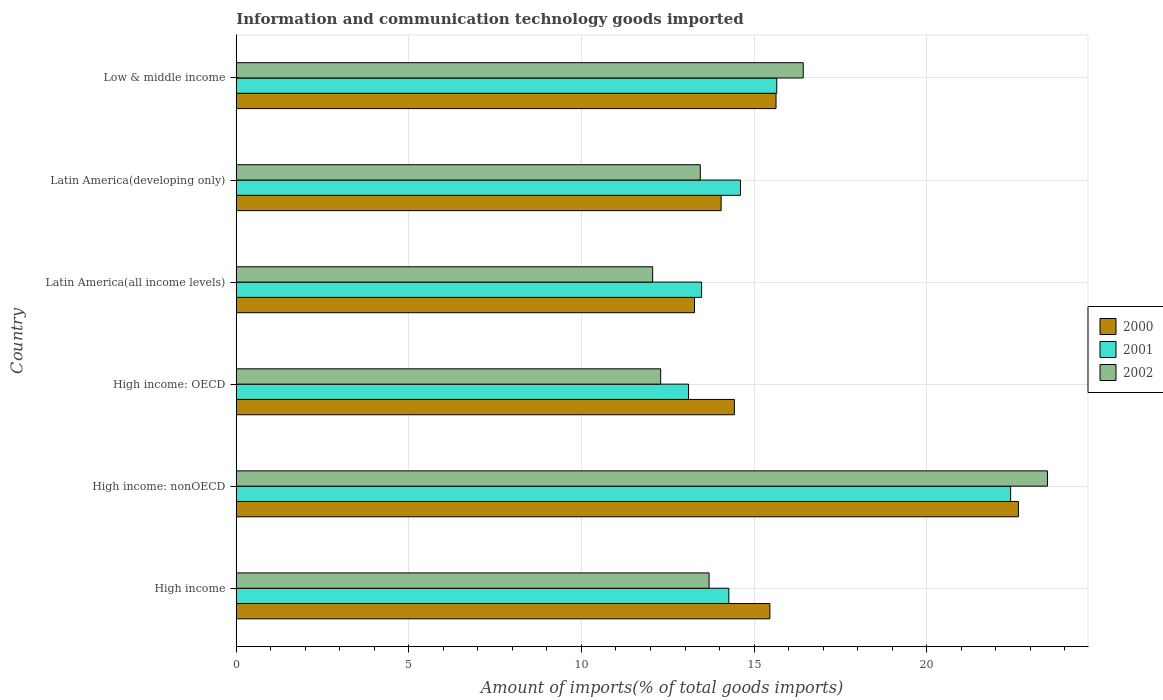How many different coloured bars are there?
Your response must be concise. 3. How many groups of bars are there?
Give a very brief answer. 6. Are the number of bars on each tick of the Y-axis equal?
Make the answer very short. Yes. How many bars are there on the 1st tick from the top?
Keep it short and to the point. 3. What is the label of the 5th group of bars from the top?
Provide a succinct answer. High income: nonOECD. In how many cases, is the number of bars for a given country not equal to the number of legend labels?
Ensure brevity in your answer.  0. What is the amount of goods imported in 2000 in High income: OECD?
Make the answer very short. 14.43. Across all countries, what is the maximum amount of goods imported in 2000?
Offer a terse response. 22.66. Across all countries, what is the minimum amount of goods imported in 2000?
Your response must be concise. 13.27. In which country was the amount of goods imported in 2000 maximum?
Keep it short and to the point. High income: nonOECD. In which country was the amount of goods imported in 2002 minimum?
Provide a short and direct response. Latin America(all income levels). What is the total amount of goods imported in 2002 in the graph?
Offer a very short reply. 91.42. What is the difference between the amount of goods imported in 2002 in High income and that in High income: OECD?
Your response must be concise. 1.4. What is the difference between the amount of goods imported in 2000 in High income and the amount of goods imported in 2002 in High income: nonOECD?
Offer a very short reply. -8.04. What is the average amount of goods imported in 2001 per country?
Your answer should be very brief. 15.59. What is the difference between the amount of goods imported in 2001 and amount of goods imported in 2000 in Latin America(developing only)?
Your response must be concise. 0.56. In how many countries, is the amount of goods imported in 2000 greater than 7 %?
Offer a terse response. 6. What is the ratio of the amount of goods imported in 2000 in High income: OECD to that in High income: nonOECD?
Keep it short and to the point. 0.64. Is the difference between the amount of goods imported in 2001 in High income: nonOECD and Latin America(all income levels) greater than the difference between the amount of goods imported in 2000 in High income: nonOECD and Latin America(all income levels)?
Provide a short and direct response. No. What is the difference between the highest and the second highest amount of goods imported in 2000?
Provide a succinct answer. 7.02. What is the difference between the highest and the lowest amount of goods imported in 2001?
Your answer should be compact. 9.33. In how many countries, is the amount of goods imported in 2001 greater than the average amount of goods imported in 2001 taken over all countries?
Keep it short and to the point. 2. Is the sum of the amount of goods imported in 2002 in Latin America(all income levels) and Low & middle income greater than the maximum amount of goods imported in 2000 across all countries?
Keep it short and to the point. Yes. What does the 3rd bar from the bottom in High income: OECD represents?
Your answer should be very brief. 2002. How many bars are there?
Make the answer very short. 18. Are all the bars in the graph horizontal?
Your response must be concise. Yes. What is the difference between two consecutive major ticks on the X-axis?
Ensure brevity in your answer.  5. Does the graph contain any zero values?
Give a very brief answer. No. Where does the legend appear in the graph?
Your response must be concise. Center right. How many legend labels are there?
Give a very brief answer. 3. What is the title of the graph?
Ensure brevity in your answer.  Information and communication technology goods imported. What is the label or title of the X-axis?
Provide a short and direct response. Amount of imports(% of total goods imports). What is the label or title of the Y-axis?
Keep it short and to the point. Country. What is the Amount of imports(% of total goods imports) in 2000 in High income?
Offer a terse response. 15.46. What is the Amount of imports(% of total goods imports) of 2001 in High income?
Keep it short and to the point. 14.27. What is the Amount of imports(% of total goods imports) of 2002 in High income?
Give a very brief answer. 13.7. What is the Amount of imports(% of total goods imports) in 2000 in High income: nonOECD?
Offer a very short reply. 22.66. What is the Amount of imports(% of total goods imports) in 2001 in High income: nonOECD?
Give a very brief answer. 22.43. What is the Amount of imports(% of total goods imports) of 2002 in High income: nonOECD?
Provide a succinct answer. 23.5. What is the Amount of imports(% of total goods imports) in 2000 in High income: OECD?
Give a very brief answer. 14.43. What is the Amount of imports(% of total goods imports) in 2001 in High income: OECD?
Provide a succinct answer. 13.1. What is the Amount of imports(% of total goods imports) of 2002 in High income: OECD?
Offer a very short reply. 12.3. What is the Amount of imports(% of total goods imports) of 2000 in Latin America(all income levels)?
Make the answer very short. 13.27. What is the Amount of imports(% of total goods imports) of 2001 in Latin America(all income levels)?
Ensure brevity in your answer.  13.48. What is the Amount of imports(% of total goods imports) of 2002 in Latin America(all income levels)?
Offer a very short reply. 12.06. What is the Amount of imports(% of total goods imports) in 2000 in Latin America(developing only)?
Make the answer very short. 14.05. What is the Amount of imports(% of total goods imports) of 2001 in Latin America(developing only)?
Your answer should be compact. 14.61. What is the Amount of imports(% of total goods imports) in 2002 in Latin America(developing only)?
Make the answer very short. 13.44. What is the Amount of imports(% of total goods imports) of 2000 in Low & middle income?
Make the answer very short. 15.64. What is the Amount of imports(% of total goods imports) in 2001 in Low & middle income?
Your answer should be very brief. 15.66. What is the Amount of imports(% of total goods imports) of 2002 in Low & middle income?
Your answer should be compact. 16.42. Across all countries, what is the maximum Amount of imports(% of total goods imports) of 2000?
Provide a succinct answer. 22.66. Across all countries, what is the maximum Amount of imports(% of total goods imports) of 2001?
Ensure brevity in your answer.  22.43. Across all countries, what is the maximum Amount of imports(% of total goods imports) of 2002?
Your response must be concise. 23.5. Across all countries, what is the minimum Amount of imports(% of total goods imports) of 2000?
Give a very brief answer. 13.27. Across all countries, what is the minimum Amount of imports(% of total goods imports) of 2001?
Offer a terse response. 13.1. Across all countries, what is the minimum Amount of imports(% of total goods imports) in 2002?
Make the answer very short. 12.06. What is the total Amount of imports(% of total goods imports) of 2000 in the graph?
Offer a very short reply. 95.5. What is the total Amount of imports(% of total goods imports) of 2001 in the graph?
Ensure brevity in your answer.  93.55. What is the total Amount of imports(% of total goods imports) of 2002 in the graph?
Provide a succinct answer. 91.42. What is the difference between the Amount of imports(% of total goods imports) of 2000 in High income and that in High income: nonOECD?
Offer a terse response. -7.2. What is the difference between the Amount of imports(% of total goods imports) in 2001 in High income and that in High income: nonOECD?
Your answer should be compact. -8.16. What is the difference between the Amount of imports(% of total goods imports) of 2002 in High income and that in High income: nonOECD?
Offer a terse response. -9.8. What is the difference between the Amount of imports(% of total goods imports) in 2000 in High income and that in High income: OECD?
Offer a terse response. 1.03. What is the difference between the Amount of imports(% of total goods imports) of 2001 in High income and that in High income: OECD?
Your answer should be very brief. 1.17. What is the difference between the Amount of imports(% of total goods imports) in 2002 in High income and that in High income: OECD?
Your response must be concise. 1.4. What is the difference between the Amount of imports(% of total goods imports) in 2000 in High income and that in Latin America(all income levels)?
Ensure brevity in your answer.  2.18. What is the difference between the Amount of imports(% of total goods imports) of 2001 in High income and that in Latin America(all income levels)?
Offer a terse response. 0.79. What is the difference between the Amount of imports(% of total goods imports) of 2002 in High income and that in Latin America(all income levels)?
Give a very brief answer. 1.63. What is the difference between the Amount of imports(% of total goods imports) of 2000 in High income and that in Latin America(developing only)?
Give a very brief answer. 1.41. What is the difference between the Amount of imports(% of total goods imports) in 2001 in High income and that in Latin America(developing only)?
Your answer should be compact. -0.34. What is the difference between the Amount of imports(% of total goods imports) in 2002 in High income and that in Latin America(developing only)?
Your response must be concise. 0.25. What is the difference between the Amount of imports(% of total goods imports) of 2000 in High income and that in Low & middle income?
Make the answer very short. -0.18. What is the difference between the Amount of imports(% of total goods imports) in 2001 in High income and that in Low & middle income?
Offer a very short reply. -1.39. What is the difference between the Amount of imports(% of total goods imports) in 2002 in High income and that in Low & middle income?
Offer a very short reply. -2.73. What is the difference between the Amount of imports(% of total goods imports) in 2000 in High income: nonOECD and that in High income: OECD?
Provide a succinct answer. 8.23. What is the difference between the Amount of imports(% of total goods imports) in 2001 in High income: nonOECD and that in High income: OECD?
Make the answer very short. 9.33. What is the difference between the Amount of imports(% of total goods imports) in 2002 in High income: nonOECD and that in High income: OECD?
Provide a succinct answer. 11.2. What is the difference between the Amount of imports(% of total goods imports) of 2000 in High income: nonOECD and that in Latin America(all income levels)?
Your response must be concise. 9.38. What is the difference between the Amount of imports(% of total goods imports) of 2001 in High income: nonOECD and that in Latin America(all income levels)?
Keep it short and to the point. 8.95. What is the difference between the Amount of imports(% of total goods imports) of 2002 in High income: nonOECD and that in Latin America(all income levels)?
Ensure brevity in your answer.  11.44. What is the difference between the Amount of imports(% of total goods imports) of 2000 in High income: nonOECD and that in Latin America(developing only)?
Offer a very short reply. 8.61. What is the difference between the Amount of imports(% of total goods imports) of 2001 in High income: nonOECD and that in Latin America(developing only)?
Your answer should be very brief. 7.83. What is the difference between the Amount of imports(% of total goods imports) of 2002 in High income: nonOECD and that in Latin America(developing only)?
Make the answer very short. 10.06. What is the difference between the Amount of imports(% of total goods imports) of 2000 in High income: nonOECD and that in Low & middle income?
Make the answer very short. 7.02. What is the difference between the Amount of imports(% of total goods imports) of 2001 in High income: nonOECD and that in Low & middle income?
Keep it short and to the point. 6.78. What is the difference between the Amount of imports(% of total goods imports) of 2002 in High income: nonOECD and that in Low & middle income?
Ensure brevity in your answer.  7.07. What is the difference between the Amount of imports(% of total goods imports) of 2000 in High income: OECD and that in Latin America(all income levels)?
Ensure brevity in your answer.  1.15. What is the difference between the Amount of imports(% of total goods imports) of 2001 in High income: OECD and that in Latin America(all income levels)?
Keep it short and to the point. -0.38. What is the difference between the Amount of imports(% of total goods imports) of 2002 in High income: OECD and that in Latin America(all income levels)?
Provide a succinct answer. 0.23. What is the difference between the Amount of imports(% of total goods imports) of 2000 in High income: OECD and that in Latin America(developing only)?
Your response must be concise. 0.38. What is the difference between the Amount of imports(% of total goods imports) of 2001 in High income: OECD and that in Latin America(developing only)?
Ensure brevity in your answer.  -1.5. What is the difference between the Amount of imports(% of total goods imports) in 2002 in High income: OECD and that in Latin America(developing only)?
Keep it short and to the point. -1.15. What is the difference between the Amount of imports(% of total goods imports) of 2000 in High income: OECD and that in Low & middle income?
Make the answer very short. -1.21. What is the difference between the Amount of imports(% of total goods imports) of 2001 in High income: OECD and that in Low & middle income?
Offer a very short reply. -2.56. What is the difference between the Amount of imports(% of total goods imports) in 2002 in High income: OECD and that in Low & middle income?
Provide a short and direct response. -4.13. What is the difference between the Amount of imports(% of total goods imports) in 2000 in Latin America(all income levels) and that in Latin America(developing only)?
Your response must be concise. -0.77. What is the difference between the Amount of imports(% of total goods imports) of 2001 in Latin America(all income levels) and that in Latin America(developing only)?
Make the answer very short. -1.13. What is the difference between the Amount of imports(% of total goods imports) in 2002 in Latin America(all income levels) and that in Latin America(developing only)?
Your answer should be compact. -1.38. What is the difference between the Amount of imports(% of total goods imports) of 2000 in Latin America(all income levels) and that in Low & middle income?
Your response must be concise. -2.36. What is the difference between the Amount of imports(% of total goods imports) of 2001 in Latin America(all income levels) and that in Low & middle income?
Your answer should be compact. -2.18. What is the difference between the Amount of imports(% of total goods imports) of 2002 in Latin America(all income levels) and that in Low & middle income?
Provide a short and direct response. -4.36. What is the difference between the Amount of imports(% of total goods imports) in 2000 in Latin America(developing only) and that in Low & middle income?
Your response must be concise. -1.59. What is the difference between the Amount of imports(% of total goods imports) in 2001 in Latin America(developing only) and that in Low & middle income?
Offer a terse response. -1.05. What is the difference between the Amount of imports(% of total goods imports) in 2002 in Latin America(developing only) and that in Low & middle income?
Ensure brevity in your answer.  -2.98. What is the difference between the Amount of imports(% of total goods imports) in 2000 in High income and the Amount of imports(% of total goods imports) in 2001 in High income: nonOECD?
Offer a very short reply. -6.97. What is the difference between the Amount of imports(% of total goods imports) of 2000 in High income and the Amount of imports(% of total goods imports) of 2002 in High income: nonOECD?
Give a very brief answer. -8.04. What is the difference between the Amount of imports(% of total goods imports) of 2001 in High income and the Amount of imports(% of total goods imports) of 2002 in High income: nonOECD?
Your answer should be very brief. -9.23. What is the difference between the Amount of imports(% of total goods imports) in 2000 in High income and the Amount of imports(% of total goods imports) in 2001 in High income: OECD?
Give a very brief answer. 2.36. What is the difference between the Amount of imports(% of total goods imports) of 2000 in High income and the Amount of imports(% of total goods imports) of 2002 in High income: OECD?
Give a very brief answer. 3.16. What is the difference between the Amount of imports(% of total goods imports) in 2001 in High income and the Amount of imports(% of total goods imports) in 2002 in High income: OECD?
Provide a short and direct response. 1.97. What is the difference between the Amount of imports(% of total goods imports) in 2000 in High income and the Amount of imports(% of total goods imports) in 2001 in Latin America(all income levels)?
Make the answer very short. 1.98. What is the difference between the Amount of imports(% of total goods imports) of 2000 in High income and the Amount of imports(% of total goods imports) of 2002 in Latin America(all income levels)?
Offer a very short reply. 3.4. What is the difference between the Amount of imports(% of total goods imports) in 2001 in High income and the Amount of imports(% of total goods imports) in 2002 in Latin America(all income levels)?
Offer a terse response. 2.21. What is the difference between the Amount of imports(% of total goods imports) in 2000 in High income and the Amount of imports(% of total goods imports) in 2001 in Latin America(developing only)?
Provide a short and direct response. 0.85. What is the difference between the Amount of imports(% of total goods imports) in 2000 in High income and the Amount of imports(% of total goods imports) in 2002 in Latin America(developing only)?
Your answer should be very brief. 2.02. What is the difference between the Amount of imports(% of total goods imports) in 2001 in High income and the Amount of imports(% of total goods imports) in 2002 in Latin America(developing only)?
Make the answer very short. 0.83. What is the difference between the Amount of imports(% of total goods imports) of 2000 in High income and the Amount of imports(% of total goods imports) of 2001 in Low & middle income?
Offer a very short reply. -0.2. What is the difference between the Amount of imports(% of total goods imports) of 2000 in High income and the Amount of imports(% of total goods imports) of 2002 in Low & middle income?
Provide a short and direct response. -0.97. What is the difference between the Amount of imports(% of total goods imports) in 2001 in High income and the Amount of imports(% of total goods imports) in 2002 in Low & middle income?
Provide a short and direct response. -2.15. What is the difference between the Amount of imports(% of total goods imports) in 2000 in High income: nonOECD and the Amount of imports(% of total goods imports) in 2001 in High income: OECD?
Give a very brief answer. 9.56. What is the difference between the Amount of imports(% of total goods imports) of 2000 in High income: nonOECD and the Amount of imports(% of total goods imports) of 2002 in High income: OECD?
Provide a short and direct response. 10.36. What is the difference between the Amount of imports(% of total goods imports) of 2001 in High income: nonOECD and the Amount of imports(% of total goods imports) of 2002 in High income: OECD?
Keep it short and to the point. 10.14. What is the difference between the Amount of imports(% of total goods imports) of 2000 in High income: nonOECD and the Amount of imports(% of total goods imports) of 2001 in Latin America(all income levels)?
Your answer should be compact. 9.18. What is the difference between the Amount of imports(% of total goods imports) of 2000 in High income: nonOECD and the Amount of imports(% of total goods imports) of 2002 in Latin America(all income levels)?
Give a very brief answer. 10.6. What is the difference between the Amount of imports(% of total goods imports) in 2001 in High income: nonOECD and the Amount of imports(% of total goods imports) in 2002 in Latin America(all income levels)?
Offer a very short reply. 10.37. What is the difference between the Amount of imports(% of total goods imports) of 2000 in High income: nonOECD and the Amount of imports(% of total goods imports) of 2001 in Latin America(developing only)?
Provide a succinct answer. 8.05. What is the difference between the Amount of imports(% of total goods imports) of 2000 in High income: nonOECD and the Amount of imports(% of total goods imports) of 2002 in Latin America(developing only)?
Give a very brief answer. 9.22. What is the difference between the Amount of imports(% of total goods imports) of 2001 in High income: nonOECD and the Amount of imports(% of total goods imports) of 2002 in Latin America(developing only)?
Offer a terse response. 8.99. What is the difference between the Amount of imports(% of total goods imports) of 2000 in High income: nonOECD and the Amount of imports(% of total goods imports) of 2001 in Low & middle income?
Ensure brevity in your answer.  7. What is the difference between the Amount of imports(% of total goods imports) in 2000 in High income: nonOECD and the Amount of imports(% of total goods imports) in 2002 in Low & middle income?
Keep it short and to the point. 6.23. What is the difference between the Amount of imports(% of total goods imports) in 2001 in High income: nonOECD and the Amount of imports(% of total goods imports) in 2002 in Low & middle income?
Offer a very short reply. 6.01. What is the difference between the Amount of imports(% of total goods imports) of 2000 in High income: OECD and the Amount of imports(% of total goods imports) of 2001 in Latin America(all income levels)?
Keep it short and to the point. 0.95. What is the difference between the Amount of imports(% of total goods imports) in 2000 in High income: OECD and the Amount of imports(% of total goods imports) in 2002 in Latin America(all income levels)?
Offer a terse response. 2.37. What is the difference between the Amount of imports(% of total goods imports) of 2001 in High income: OECD and the Amount of imports(% of total goods imports) of 2002 in Latin America(all income levels)?
Keep it short and to the point. 1.04. What is the difference between the Amount of imports(% of total goods imports) in 2000 in High income: OECD and the Amount of imports(% of total goods imports) in 2001 in Latin America(developing only)?
Provide a short and direct response. -0.18. What is the difference between the Amount of imports(% of total goods imports) in 2000 in High income: OECD and the Amount of imports(% of total goods imports) in 2002 in Latin America(developing only)?
Ensure brevity in your answer.  0.99. What is the difference between the Amount of imports(% of total goods imports) in 2001 in High income: OECD and the Amount of imports(% of total goods imports) in 2002 in Latin America(developing only)?
Offer a terse response. -0.34. What is the difference between the Amount of imports(% of total goods imports) in 2000 in High income: OECD and the Amount of imports(% of total goods imports) in 2001 in Low & middle income?
Your answer should be very brief. -1.23. What is the difference between the Amount of imports(% of total goods imports) in 2000 in High income: OECD and the Amount of imports(% of total goods imports) in 2002 in Low & middle income?
Provide a succinct answer. -2. What is the difference between the Amount of imports(% of total goods imports) of 2001 in High income: OECD and the Amount of imports(% of total goods imports) of 2002 in Low & middle income?
Your answer should be compact. -3.32. What is the difference between the Amount of imports(% of total goods imports) in 2000 in Latin America(all income levels) and the Amount of imports(% of total goods imports) in 2001 in Latin America(developing only)?
Your answer should be compact. -1.33. What is the difference between the Amount of imports(% of total goods imports) of 2000 in Latin America(all income levels) and the Amount of imports(% of total goods imports) of 2002 in Latin America(developing only)?
Ensure brevity in your answer.  -0.17. What is the difference between the Amount of imports(% of total goods imports) of 2001 in Latin America(all income levels) and the Amount of imports(% of total goods imports) of 2002 in Latin America(developing only)?
Keep it short and to the point. 0.04. What is the difference between the Amount of imports(% of total goods imports) in 2000 in Latin America(all income levels) and the Amount of imports(% of total goods imports) in 2001 in Low & middle income?
Ensure brevity in your answer.  -2.38. What is the difference between the Amount of imports(% of total goods imports) in 2000 in Latin America(all income levels) and the Amount of imports(% of total goods imports) in 2002 in Low & middle income?
Ensure brevity in your answer.  -3.15. What is the difference between the Amount of imports(% of total goods imports) of 2001 in Latin America(all income levels) and the Amount of imports(% of total goods imports) of 2002 in Low & middle income?
Offer a terse response. -2.94. What is the difference between the Amount of imports(% of total goods imports) of 2000 in Latin America(developing only) and the Amount of imports(% of total goods imports) of 2001 in Low & middle income?
Offer a terse response. -1.61. What is the difference between the Amount of imports(% of total goods imports) of 2000 in Latin America(developing only) and the Amount of imports(% of total goods imports) of 2002 in Low & middle income?
Offer a very short reply. -2.38. What is the difference between the Amount of imports(% of total goods imports) of 2001 in Latin America(developing only) and the Amount of imports(% of total goods imports) of 2002 in Low & middle income?
Give a very brief answer. -1.82. What is the average Amount of imports(% of total goods imports) in 2000 per country?
Provide a succinct answer. 15.92. What is the average Amount of imports(% of total goods imports) of 2001 per country?
Your response must be concise. 15.59. What is the average Amount of imports(% of total goods imports) of 2002 per country?
Offer a terse response. 15.24. What is the difference between the Amount of imports(% of total goods imports) of 2000 and Amount of imports(% of total goods imports) of 2001 in High income?
Make the answer very short. 1.19. What is the difference between the Amount of imports(% of total goods imports) in 2000 and Amount of imports(% of total goods imports) in 2002 in High income?
Your answer should be compact. 1.76. What is the difference between the Amount of imports(% of total goods imports) of 2001 and Amount of imports(% of total goods imports) of 2002 in High income?
Provide a succinct answer. 0.57. What is the difference between the Amount of imports(% of total goods imports) of 2000 and Amount of imports(% of total goods imports) of 2001 in High income: nonOECD?
Provide a succinct answer. 0.23. What is the difference between the Amount of imports(% of total goods imports) in 2000 and Amount of imports(% of total goods imports) in 2002 in High income: nonOECD?
Your response must be concise. -0.84. What is the difference between the Amount of imports(% of total goods imports) in 2001 and Amount of imports(% of total goods imports) in 2002 in High income: nonOECD?
Your answer should be very brief. -1.07. What is the difference between the Amount of imports(% of total goods imports) in 2000 and Amount of imports(% of total goods imports) in 2001 in High income: OECD?
Offer a terse response. 1.33. What is the difference between the Amount of imports(% of total goods imports) in 2000 and Amount of imports(% of total goods imports) in 2002 in High income: OECD?
Provide a short and direct response. 2.13. What is the difference between the Amount of imports(% of total goods imports) in 2001 and Amount of imports(% of total goods imports) in 2002 in High income: OECD?
Provide a short and direct response. 0.81. What is the difference between the Amount of imports(% of total goods imports) in 2000 and Amount of imports(% of total goods imports) in 2001 in Latin America(all income levels)?
Give a very brief answer. -0.21. What is the difference between the Amount of imports(% of total goods imports) of 2000 and Amount of imports(% of total goods imports) of 2002 in Latin America(all income levels)?
Your answer should be very brief. 1.21. What is the difference between the Amount of imports(% of total goods imports) in 2001 and Amount of imports(% of total goods imports) in 2002 in Latin America(all income levels)?
Your answer should be very brief. 1.42. What is the difference between the Amount of imports(% of total goods imports) of 2000 and Amount of imports(% of total goods imports) of 2001 in Latin America(developing only)?
Give a very brief answer. -0.56. What is the difference between the Amount of imports(% of total goods imports) in 2000 and Amount of imports(% of total goods imports) in 2002 in Latin America(developing only)?
Make the answer very short. 0.6. What is the difference between the Amount of imports(% of total goods imports) in 2001 and Amount of imports(% of total goods imports) in 2002 in Latin America(developing only)?
Provide a succinct answer. 1.16. What is the difference between the Amount of imports(% of total goods imports) of 2000 and Amount of imports(% of total goods imports) of 2001 in Low & middle income?
Offer a terse response. -0.02. What is the difference between the Amount of imports(% of total goods imports) of 2000 and Amount of imports(% of total goods imports) of 2002 in Low & middle income?
Ensure brevity in your answer.  -0.79. What is the difference between the Amount of imports(% of total goods imports) of 2001 and Amount of imports(% of total goods imports) of 2002 in Low & middle income?
Ensure brevity in your answer.  -0.77. What is the ratio of the Amount of imports(% of total goods imports) in 2000 in High income to that in High income: nonOECD?
Offer a very short reply. 0.68. What is the ratio of the Amount of imports(% of total goods imports) of 2001 in High income to that in High income: nonOECD?
Make the answer very short. 0.64. What is the ratio of the Amount of imports(% of total goods imports) in 2002 in High income to that in High income: nonOECD?
Ensure brevity in your answer.  0.58. What is the ratio of the Amount of imports(% of total goods imports) of 2000 in High income to that in High income: OECD?
Your answer should be compact. 1.07. What is the ratio of the Amount of imports(% of total goods imports) of 2001 in High income to that in High income: OECD?
Your response must be concise. 1.09. What is the ratio of the Amount of imports(% of total goods imports) of 2002 in High income to that in High income: OECD?
Keep it short and to the point. 1.11. What is the ratio of the Amount of imports(% of total goods imports) in 2000 in High income to that in Latin America(all income levels)?
Ensure brevity in your answer.  1.16. What is the ratio of the Amount of imports(% of total goods imports) in 2001 in High income to that in Latin America(all income levels)?
Make the answer very short. 1.06. What is the ratio of the Amount of imports(% of total goods imports) in 2002 in High income to that in Latin America(all income levels)?
Your response must be concise. 1.14. What is the ratio of the Amount of imports(% of total goods imports) of 2000 in High income to that in Latin America(developing only)?
Offer a terse response. 1.1. What is the ratio of the Amount of imports(% of total goods imports) of 2001 in High income to that in Latin America(developing only)?
Make the answer very short. 0.98. What is the ratio of the Amount of imports(% of total goods imports) of 2002 in High income to that in Latin America(developing only)?
Ensure brevity in your answer.  1.02. What is the ratio of the Amount of imports(% of total goods imports) of 2001 in High income to that in Low & middle income?
Provide a succinct answer. 0.91. What is the ratio of the Amount of imports(% of total goods imports) of 2002 in High income to that in Low & middle income?
Your answer should be compact. 0.83. What is the ratio of the Amount of imports(% of total goods imports) of 2000 in High income: nonOECD to that in High income: OECD?
Offer a terse response. 1.57. What is the ratio of the Amount of imports(% of total goods imports) of 2001 in High income: nonOECD to that in High income: OECD?
Provide a succinct answer. 1.71. What is the ratio of the Amount of imports(% of total goods imports) of 2002 in High income: nonOECD to that in High income: OECD?
Keep it short and to the point. 1.91. What is the ratio of the Amount of imports(% of total goods imports) of 2000 in High income: nonOECD to that in Latin America(all income levels)?
Provide a succinct answer. 1.71. What is the ratio of the Amount of imports(% of total goods imports) of 2001 in High income: nonOECD to that in Latin America(all income levels)?
Your answer should be compact. 1.66. What is the ratio of the Amount of imports(% of total goods imports) in 2002 in High income: nonOECD to that in Latin America(all income levels)?
Ensure brevity in your answer.  1.95. What is the ratio of the Amount of imports(% of total goods imports) in 2000 in High income: nonOECD to that in Latin America(developing only)?
Your answer should be compact. 1.61. What is the ratio of the Amount of imports(% of total goods imports) of 2001 in High income: nonOECD to that in Latin America(developing only)?
Offer a terse response. 1.54. What is the ratio of the Amount of imports(% of total goods imports) in 2002 in High income: nonOECD to that in Latin America(developing only)?
Your answer should be compact. 1.75. What is the ratio of the Amount of imports(% of total goods imports) in 2000 in High income: nonOECD to that in Low & middle income?
Offer a terse response. 1.45. What is the ratio of the Amount of imports(% of total goods imports) of 2001 in High income: nonOECD to that in Low & middle income?
Ensure brevity in your answer.  1.43. What is the ratio of the Amount of imports(% of total goods imports) of 2002 in High income: nonOECD to that in Low & middle income?
Provide a short and direct response. 1.43. What is the ratio of the Amount of imports(% of total goods imports) of 2000 in High income: OECD to that in Latin America(all income levels)?
Your answer should be very brief. 1.09. What is the ratio of the Amount of imports(% of total goods imports) of 2001 in High income: OECD to that in Latin America(all income levels)?
Keep it short and to the point. 0.97. What is the ratio of the Amount of imports(% of total goods imports) in 2002 in High income: OECD to that in Latin America(all income levels)?
Your answer should be compact. 1.02. What is the ratio of the Amount of imports(% of total goods imports) of 2000 in High income: OECD to that in Latin America(developing only)?
Your answer should be compact. 1.03. What is the ratio of the Amount of imports(% of total goods imports) in 2001 in High income: OECD to that in Latin America(developing only)?
Give a very brief answer. 0.9. What is the ratio of the Amount of imports(% of total goods imports) of 2002 in High income: OECD to that in Latin America(developing only)?
Provide a short and direct response. 0.91. What is the ratio of the Amount of imports(% of total goods imports) of 2000 in High income: OECD to that in Low & middle income?
Give a very brief answer. 0.92. What is the ratio of the Amount of imports(% of total goods imports) in 2001 in High income: OECD to that in Low & middle income?
Provide a short and direct response. 0.84. What is the ratio of the Amount of imports(% of total goods imports) in 2002 in High income: OECD to that in Low & middle income?
Offer a very short reply. 0.75. What is the ratio of the Amount of imports(% of total goods imports) in 2000 in Latin America(all income levels) to that in Latin America(developing only)?
Your answer should be very brief. 0.95. What is the ratio of the Amount of imports(% of total goods imports) of 2001 in Latin America(all income levels) to that in Latin America(developing only)?
Your answer should be compact. 0.92. What is the ratio of the Amount of imports(% of total goods imports) in 2002 in Latin America(all income levels) to that in Latin America(developing only)?
Make the answer very short. 0.9. What is the ratio of the Amount of imports(% of total goods imports) in 2000 in Latin America(all income levels) to that in Low & middle income?
Provide a short and direct response. 0.85. What is the ratio of the Amount of imports(% of total goods imports) in 2001 in Latin America(all income levels) to that in Low & middle income?
Provide a succinct answer. 0.86. What is the ratio of the Amount of imports(% of total goods imports) in 2002 in Latin America(all income levels) to that in Low & middle income?
Keep it short and to the point. 0.73. What is the ratio of the Amount of imports(% of total goods imports) of 2000 in Latin America(developing only) to that in Low & middle income?
Provide a succinct answer. 0.9. What is the ratio of the Amount of imports(% of total goods imports) in 2001 in Latin America(developing only) to that in Low & middle income?
Your answer should be compact. 0.93. What is the ratio of the Amount of imports(% of total goods imports) in 2002 in Latin America(developing only) to that in Low & middle income?
Provide a succinct answer. 0.82. What is the difference between the highest and the second highest Amount of imports(% of total goods imports) in 2000?
Provide a succinct answer. 7.02. What is the difference between the highest and the second highest Amount of imports(% of total goods imports) of 2001?
Give a very brief answer. 6.78. What is the difference between the highest and the second highest Amount of imports(% of total goods imports) of 2002?
Your answer should be compact. 7.07. What is the difference between the highest and the lowest Amount of imports(% of total goods imports) of 2000?
Offer a terse response. 9.38. What is the difference between the highest and the lowest Amount of imports(% of total goods imports) of 2001?
Provide a succinct answer. 9.33. What is the difference between the highest and the lowest Amount of imports(% of total goods imports) in 2002?
Provide a succinct answer. 11.44. 